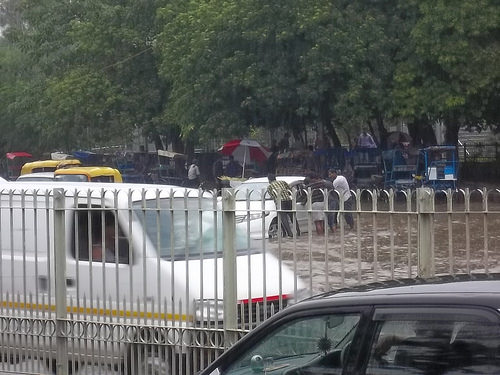<image>
Can you confirm if the van is in the water? Yes. The van is contained within or inside the water, showing a containment relationship. 